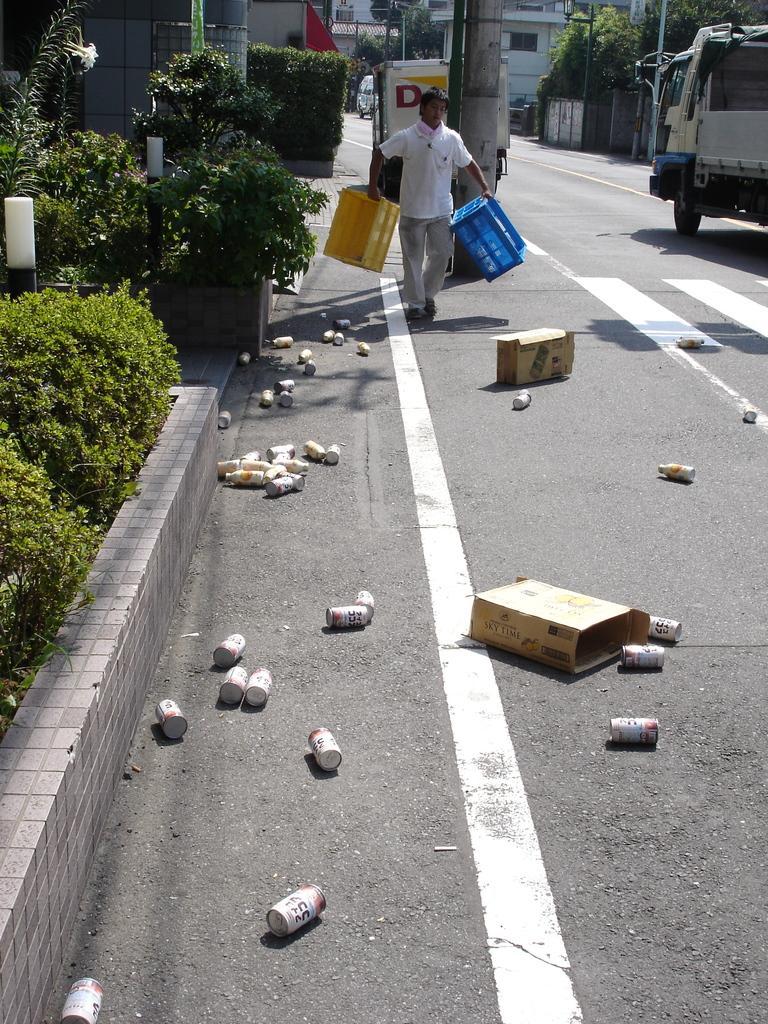How would you summarize this image in a sentence or two? In this image there is a road on which there are two cardboard boxes and there are so many tins on the road. On the right side top corner there is a truck. In the middle there is a man walking on the road by holding the two trays. On the left side there is a garden with the plants. In the background there is a pole in the middle and there are buildings on either side of the road. 